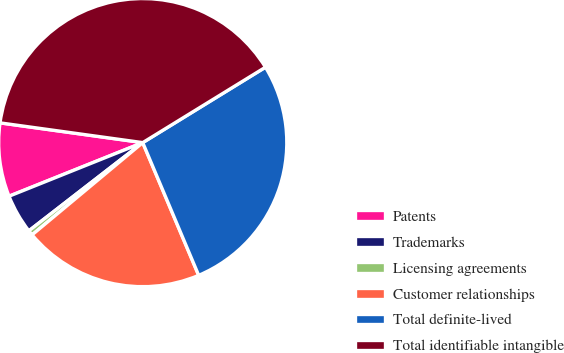Convert chart. <chart><loc_0><loc_0><loc_500><loc_500><pie_chart><fcel>Patents<fcel>Trademarks<fcel>Licensing agreements<fcel>Customer relationships<fcel>Total definite-lived<fcel>Total identifiable intangible<nl><fcel>8.26%<fcel>4.42%<fcel>0.57%<fcel>20.29%<fcel>27.42%<fcel>39.04%<nl></chart> 